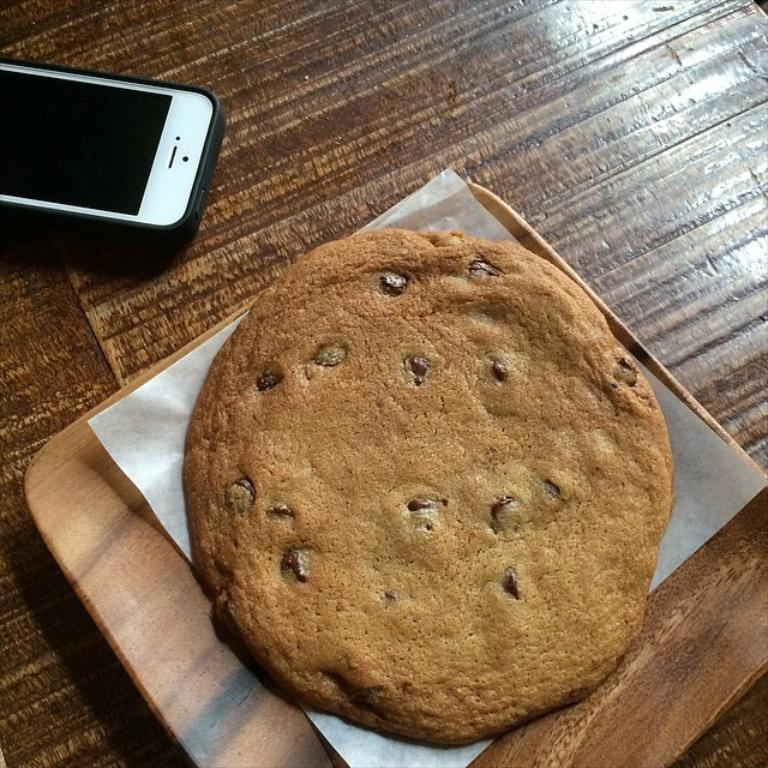What is on the plate that is visible in the image? There is a plate containing edible items in the image. What is an unusual item found on the plate? There is a tissue on the plate. What is the color of the table in the image? The table is brown in color. What electronic device is present on the table? There is a mobile phone on the table. How many spies are present in the image? There are no spies present in the image. What type of dinner is being served on the plate? The image does not specify the type of dinner being served; it only shows edible items on a plate. 